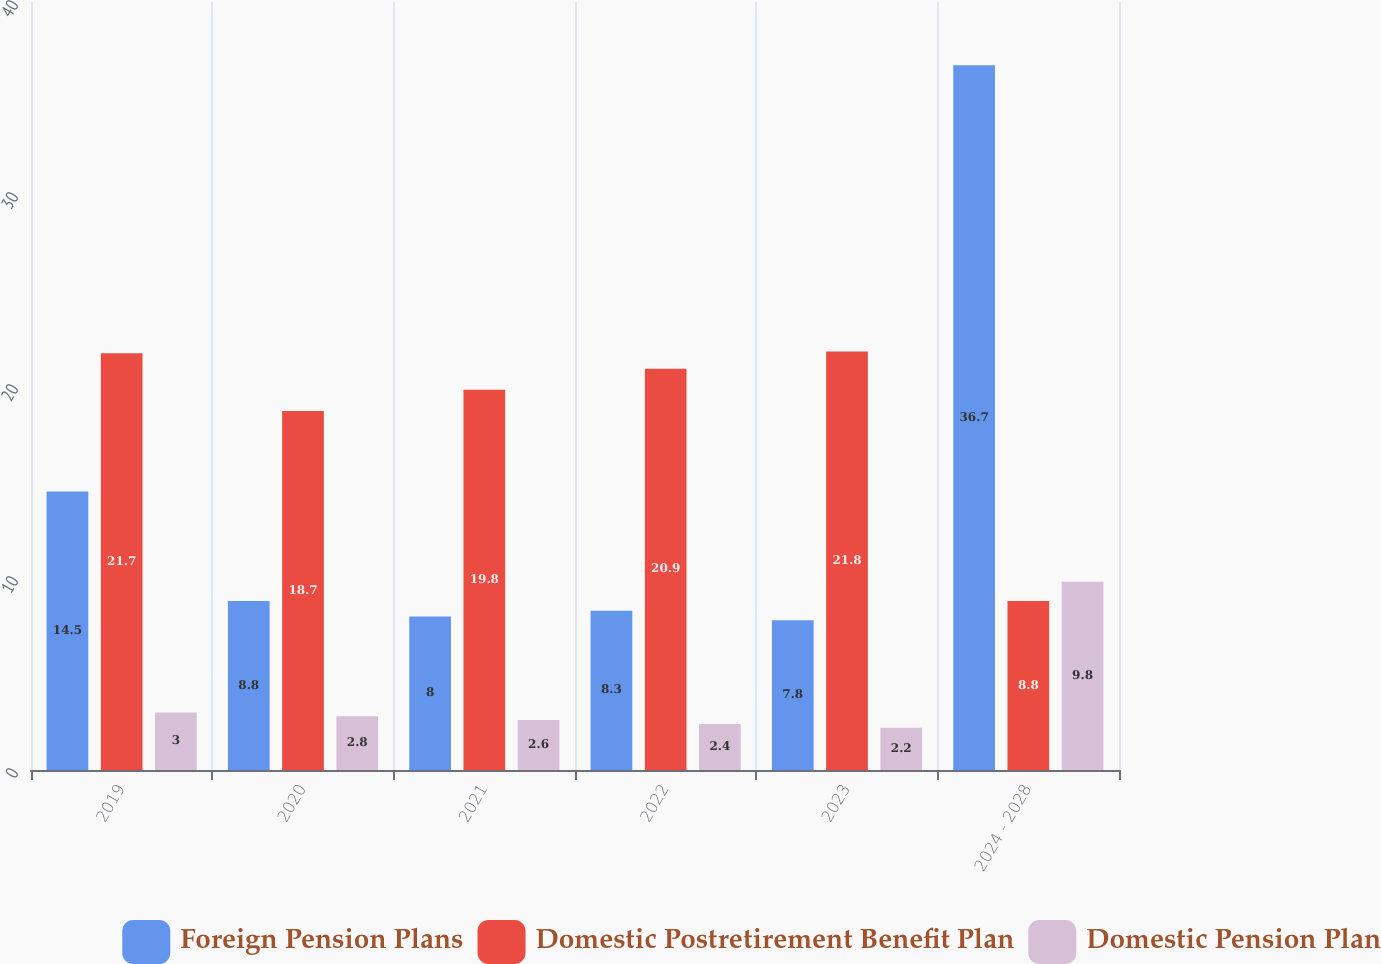<chart> <loc_0><loc_0><loc_500><loc_500><stacked_bar_chart><ecel><fcel>2019<fcel>2020<fcel>2021<fcel>2022<fcel>2023<fcel>2024 - 2028<nl><fcel>Foreign Pension Plans<fcel>14.5<fcel>8.8<fcel>8<fcel>8.3<fcel>7.8<fcel>36.7<nl><fcel>Domestic Postretirement Benefit Plan<fcel>21.7<fcel>18.7<fcel>19.8<fcel>20.9<fcel>21.8<fcel>8.8<nl><fcel>Domestic Pension Plan<fcel>3<fcel>2.8<fcel>2.6<fcel>2.4<fcel>2.2<fcel>9.8<nl></chart> 